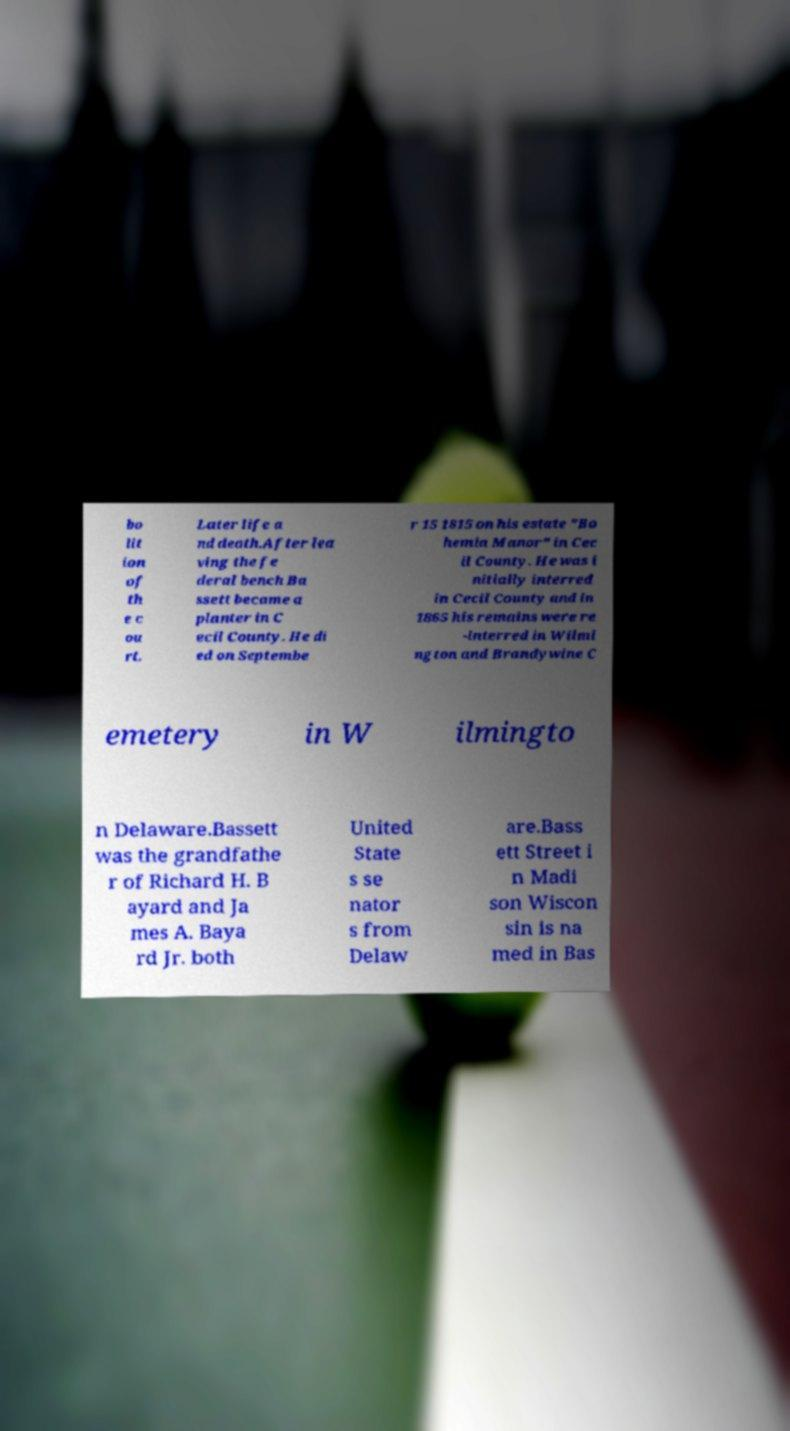What messages or text are displayed in this image? I need them in a readable, typed format. bo lit ion of th e c ou rt. Later life a nd death.After lea ving the fe deral bench Ba ssett became a planter in C ecil County. He di ed on Septembe r 15 1815 on his estate "Bo hemia Manor" in Cec il County. He was i nitially interred in Cecil County and in 1865 his remains were re -interred in Wilmi ngton and Brandywine C emetery in W ilmingto n Delaware.Bassett was the grandfathe r of Richard H. B ayard and Ja mes A. Baya rd Jr. both United State s se nator s from Delaw are.Bass ett Street i n Madi son Wiscon sin is na med in Bas 